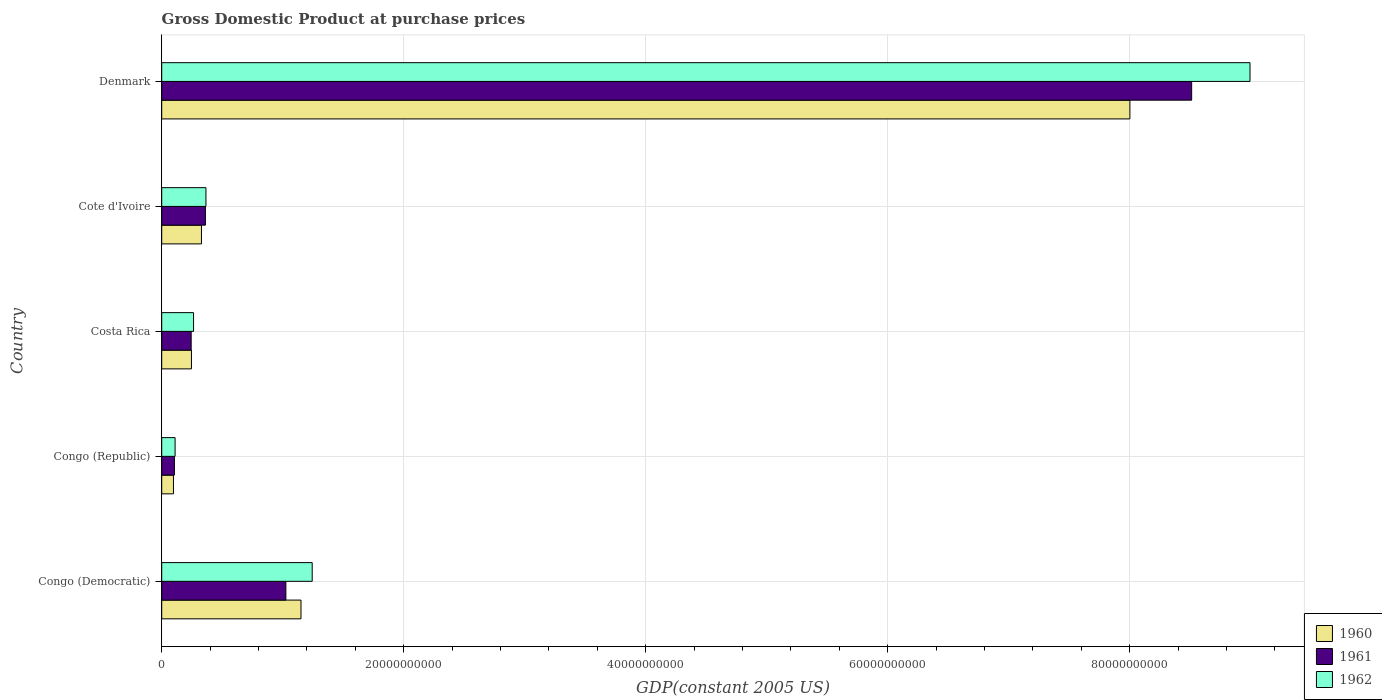How many different coloured bars are there?
Keep it short and to the point. 3. How many groups of bars are there?
Your answer should be very brief. 5. Are the number of bars on each tick of the Y-axis equal?
Ensure brevity in your answer.  Yes. How many bars are there on the 1st tick from the top?
Offer a terse response. 3. How many bars are there on the 2nd tick from the bottom?
Offer a very short reply. 3. In how many cases, is the number of bars for a given country not equal to the number of legend labels?
Give a very brief answer. 0. What is the GDP at purchase prices in 1960 in Costa Rica?
Provide a succinct answer. 2.46e+09. Across all countries, what is the maximum GDP at purchase prices in 1961?
Your answer should be very brief. 8.51e+1. Across all countries, what is the minimum GDP at purchase prices in 1960?
Your answer should be compact. 9.70e+08. In which country was the GDP at purchase prices in 1962 maximum?
Your answer should be compact. Denmark. In which country was the GDP at purchase prices in 1962 minimum?
Offer a terse response. Congo (Republic). What is the total GDP at purchase prices in 1960 in the graph?
Give a very brief answer. 9.82e+1. What is the difference between the GDP at purchase prices in 1961 in Congo (Democratic) and that in Congo (Republic)?
Your answer should be compact. 9.21e+09. What is the difference between the GDP at purchase prices in 1960 in Denmark and the GDP at purchase prices in 1962 in Cote d'Ivoire?
Ensure brevity in your answer.  7.64e+1. What is the average GDP at purchase prices in 1962 per country?
Your answer should be very brief. 2.20e+1. What is the difference between the GDP at purchase prices in 1962 and GDP at purchase prices in 1960 in Denmark?
Give a very brief answer. 9.93e+09. In how many countries, is the GDP at purchase prices in 1960 greater than 84000000000 US$?
Your answer should be very brief. 0. What is the ratio of the GDP at purchase prices in 1962 in Congo (Democratic) to that in Denmark?
Keep it short and to the point. 0.14. What is the difference between the highest and the second highest GDP at purchase prices in 1961?
Give a very brief answer. 7.49e+1. What is the difference between the highest and the lowest GDP at purchase prices in 1962?
Keep it short and to the point. 8.88e+1. Is the sum of the GDP at purchase prices in 1962 in Congo (Democratic) and Costa Rica greater than the maximum GDP at purchase prices in 1961 across all countries?
Offer a very short reply. No. What does the 2nd bar from the top in Congo (Democratic) represents?
Keep it short and to the point. 1961. How many bars are there?
Ensure brevity in your answer.  15. Are all the bars in the graph horizontal?
Offer a terse response. Yes. How many countries are there in the graph?
Make the answer very short. 5. What is the difference between two consecutive major ticks on the X-axis?
Your response must be concise. 2.00e+1. Does the graph contain any zero values?
Provide a succinct answer. No. Does the graph contain grids?
Offer a very short reply. Yes. Where does the legend appear in the graph?
Give a very brief answer. Bottom right. How many legend labels are there?
Keep it short and to the point. 3. What is the title of the graph?
Your answer should be compact. Gross Domestic Product at purchase prices. What is the label or title of the X-axis?
Your response must be concise. GDP(constant 2005 US). What is the GDP(constant 2005 US) in 1960 in Congo (Democratic)?
Your answer should be compact. 1.15e+1. What is the GDP(constant 2005 US) of 1961 in Congo (Democratic)?
Your answer should be very brief. 1.03e+1. What is the GDP(constant 2005 US) in 1962 in Congo (Democratic)?
Keep it short and to the point. 1.24e+1. What is the GDP(constant 2005 US) of 1960 in Congo (Republic)?
Provide a short and direct response. 9.70e+08. What is the GDP(constant 2005 US) of 1961 in Congo (Republic)?
Your answer should be compact. 1.05e+09. What is the GDP(constant 2005 US) of 1962 in Congo (Republic)?
Your answer should be compact. 1.11e+09. What is the GDP(constant 2005 US) of 1960 in Costa Rica?
Give a very brief answer. 2.46e+09. What is the GDP(constant 2005 US) of 1961 in Costa Rica?
Ensure brevity in your answer.  2.43e+09. What is the GDP(constant 2005 US) in 1962 in Costa Rica?
Provide a short and direct response. 2.63e+09. What is the GDP(constant 2005 US) of 1960 in Cote d'Ivoire?
Offer a very short reply. 3.29e+09. What is the GDP(constant 2005 US) of 1961 in Cote d'Ivoire?
Your answer should be very brief. 3.61e+09. What is the GDP(constant 2005 US) in 1962 in Cote d'Ivoire?
Provide a short and direct response. 3.66e+09. What is the GDP(constant 2005 US) of 1960 in Denmark?
Give a very brief answer. 8.00e+1. What is the GDP(constant 2005 US) of 1961 in Denmark?
Offer a very short reply. 8.51e+1. What is the GDP(constant 2005 US) in 1962 in Denmark?
Provide a short and direct response. 8.99e+1. Across all countries, what is the maximum GDP(constant 2005 US) in 1960?
Provide a short and direct response. 8.00e+1. Across all countries, what is the maximum GDP(constant 2005 US) of 1961?
Provide a succinct answer. 8.51e+1. Across all countries, what is the maximum GDP(constant 2005 US) in 1962?
Provide a succinct answer. 8.99e+1. Across all countries, what is the minimum GDP(constant 2005 US) in 1960?
Ensure brevity in your answer.  9.70e+08. Across all countries, what is the minimum GDP(constant 2005 US) of 1961?
Give a very brief answer. 1.05e+09. Across all countries, what is the minimum GDP(constant 2005 US) of 1962?
Keep it short and to the point. 1.11e+09. What is the total GDP(constant 2005 US) in 1960 in the graph?
Give a very brief answer. 9.82e+1. What is the total GDP(constant 2005 US) of 1961 in the graph?
Give a very brief answer. 1.02e+11. What is the total GDP(constant 2005 US) in 1962 in the graph?
Ensure brevity in your answer.  1.10e+11. What is the difference between the GDP(constant 2005 US) in 1960 in Congo (Democratic) and that in Congo (Republic)?
Your response must be concise. 1.05e+1. What is the difference between the GDP(constant 2005 US) of 1961 in Congo (Democratic) and that in Congo (Republic)?
Your response must be concise. 9.21e+09. What is the difference between the GDP(constant 2005 US) in 1962 in Congo (Democratic) and that in Congo (Republic)?
Your answer should be very brief. 1.13e+1. What is the difference between the GDP(constant 2005 US) of 1960 in Congo (Democratic) and that in Costa Rica?
Keep it short and to the point. 9.05e+09. What is the difference between the GDP(constant 2005 US) of 1961 in Congo (Democratic) and that in Costa Rica?
Give a very brief answer. 7.83e+09. What is the difference between the GDP(constant 2005 US) of 1962 in Congo (Democratic) and that in Costa Rica?
Ensure brevity in your answer.  9.80e+09. What is the difference between the GDP(constant 2005 US) of 1960 in Congo (Democratic) and that in Cote d'Ivoire?
Offer a very short reply. 8.22e+09. What is the difference between the GDP(constant 2005 US) in 1961 in Congo (Democratic) and that in Cote d'Ivoire?
Make the answer very short. 6.65e+09. What is the difference between the GDP(constant 2005 US) of 1962 in Congo (Democratic) and that in Cote d'Ivoire?
Provide a short and direct response. 8.78e+09. What is the difference between the GDP(constant 2005 US) of 1960 in Congo (Democratic) and that in Denmark?
Your answer should be very brief. -6.85e+1. What is the difference between the GDP(constant 2005 US) in 1961 in Congo (Democratic) and that in Denmark?
Offer a terse response. -7.49e+1. What is the difference between the GDP(constant 2005 US) of 1962 in Congo (Democratic) and that in Denmark?
Keep it short and to the point. -7.75e+1. What is the difference between the GDP(constant 2005 US) in 1960 in Congo (Republic) and that in Costa Rica?
Your response must be concise. -1.49e+09. What is the difference between the GDP(constant 2005 US) in 1961 in Congo (Republic) and that in Costa Rica?
Give a very brief answer. -1.38e+09. What is the difference between the GDP(constant 2005 US) of 1962 in Congo (Republic) and that in Costa Rica?
Offer a very short reply. -1.53e+09. What is the difference between the GDP(constant 2005 US) in 1960 in Congo (Republic) and that in Cote d'Ivoire?
Make the answer very short. -2.32e+09. What is the difference between the GDP(constant 2005 US) in 1961 in Congo (Republic) and that in Cote d'Ivoire?
Make the answer very short. -2.56e+09. What is the difference between the GDP(constant 2005 US) of 1962 in Congo (Republic) and that in Cote d'Ivoire?
Keep it short and to the point. -2.55e+09. What is the difference between the GDP(constant 2005 US) of 1960 in Congo (Republic) and that in Denmark?
Provide a succinct answer. -7.90e+1. What is the difference between the GDP(constant 2005 US) in 1961 in Congo (Republic) and that in Denmark?
Make the answer very short. -8.41e+1. What is the difference between the GDP(constant 2005 US) of 1962 in Congo (Republic) and that in Denmark?
Ensure brevity in your answer.  -8.88e+1. What is the difference between the GDP(constant 2005 US) in 1960 in Costa Rica and that in Cote d'Ivoire?
Offer a very short reply. -8.28e+08. What is the difference between the GDP(constant 2005 US) of 1961 in Costa Rica and that in Cote d'Ivoire?
Ensure brevity in your answer.  -1.18e+09. What is the difference between the GDP(constant 2005 US) in 1962 in Costa Rica and that in Cote d'Ivoire?
Provide a succinct answer. -1.02e+09. What is the difference between the GDP(constant 2005 US) in 1960 in Costa Rica and that in Denmark?
Your answer should be compact. -7.76e+1. What is the difference between the GDP(constant 2005 US) of 1961 in Costa Rica and that in Denmark?
Make the answer very short. -8.27e+1. What is the difference between the GDP(constant 2005 US) of 1962 in Costa Rica and that in Denmark?
Keep it short and to the point. -8.73e+1. What is the difference between the GDP(constant 2005 US) of 1960 in Cote d'Ivoire and that in Denmark?
Keep it short and to the point. -7.67e+1. What is the difference between the GDP(constant 2005 US) of 1961 in Cote d'Ivoire and that in Denmark?
Your answer should be very brief. -8.15e+1. What is the difference between the GDP(constant 2005 US) of 1962 in Cote d'Ivoire and that in Denmark?
Your answer should be very brief. -8.63e+1. What is the difference between the GDP(constant 2005 US) of 1960 in Congo (Democratic) and the GDP(constant 2005 US) of 1961 in Congo (Republic)?
Provide a short and direct response. 1.05e+1. What is the difference between the GDP(constant 2005 US) of 1960 in Congo (Democratic) and the GDP(constant 2005 US) of 1962 in Congo (Republic)?
Offer a terse response. 1.04e+1. What is the difference between the GDP(constant 2005 US) in 1961 in Congo (Democratic) and the GDP(constant 2005 US) in 1962 in Congo (Republic)?
Make the answer very short. 9.16e+09. What is the difference between the GDP(constant 2005 US) of 1960 in Congo (Democratic) and the GDP(constant 2005 US) of 1961 in Costa Rica?
Provide a short and direct response. 9.08e+09. What is the difference between the GDP(constant 2005 US) of 1960 in Congo (Democratic) and the GDP(constant 2005 US) of 1962 in Costa Rica?
Your answer should be compact. 8.88e+09. What is the difference between the GDP(constant 2005 US) in 1961 in Congo (Democratic) and the GDP(constant 2005 US) in 1962 in Costa Rica?
Provide a succinct answer. 7.63e+09. What is the difference between the GDP(constant 2005 US) in 1960 in Congo (Democratic) and the GDP(constant 2005 US) in 1961 in Cote d'Ivoire?
Ensure brevity in your answer.  7.90e+09. What is the difference between the GDP(constant 2005 US) in 1960 in Congo (Democratic) and the GDP(constant 2005 US) in 1962 in Cote d'Ivoire?
Your answer should be compact. 7.85e+09. What is the difference between the GDP(constant 2005 US) of 1961 in Congo (Democratic) and the GDP(constant 2005 US) of 1962 in Cote d'Ivoire?
Keep it short and to the point. 6.60e+09. What is the difference between the GDP(constant 2005 US) in 1960 in Congo (Democratic) and the GDP(constant 2005 US) in 1961 in Denmark?
Keep it short and to the point. -7.36e+1. What is the difference between the GDP(constant 2005 US) of 1960 in Congo (Democratic) and the GDP(constant 2005 US) of 1962 in Denmark?
Provide a succinct answer. -7.84e+1. What is the difference between the GDP(constant 2005 US) in 1961 in Congo (Democratic) and the GDP(constant 2005 US) in 1962 in Denmark?
Provide a short and direct response. -7.97e+1. What is the difference between the GDP(constant 2005 US) in 1960 in Congo (Republic) and the GDP(constant 2005 US) in 1961 in Costa Rica?
Provide a short and direct response. -1.46e+09. What is the difference between the GDP(constant 2005 US) in 1960 in Congo (Republic) and the GDP(constant 2005 US) in 1962 in Costa Rica?
Your answer should be compact. -1.66e+09. What is the difference between the GDP(constant 2005 US) of 1961 in Congo (Republic) and the GDP(constant 2005 US) of 1962 in Costa Rica?
Give a very brief answer. -1.58e+09. What is the difference between the GDP(constant 2005 US) of 1960 in Congo (Republic) and the GDP(constant 2005 US) of 1961 in Cote d'Ivoire?
Your response must be concise. -2.64e+09. What is the difference between the GDP(constant 2005 US) of 1960 in Congo (Republic) and the GDP(constant 2005 US) of 1962 in Cote d'Ivoire?
Your response must be concise. -2.69e+09. What is the difference between the GDP(constant 2005 US) in 1961 in Congo (Republic) and the GDP(constant 2005 US) in 1962 in Cote d'Ivoire?
Your answer should be very brief. -2.61e+09. What is the difference between the GDP(constant 2005 US) of 1960 in Congo (Republic) and the GDP(constant 2005 US) of 1961 in Denmark?
Ensure brevity in your answer.  -8.42e+1. What is the difference between the GDP(constant 2005 US) of 1960 in Congo (Republic) and the GDP(constant 2005 US) of 1962 in Denmark?
Offer a very short reply. -8.90e+1. What is the difference between the GDP(constant 2005 US) in 1961 in Congo (Republic) and the GDP(constant 2005 US) in 1962 in Denmark?
Your answer should be compact. -8.89e+1. What is the difference between the GDP(constant 2005 US) of 1960 in Costa Rica and the GDP(constant 2005 US) of 1961 in Cote d'Ivoire?
Keep it short and to the point. -1.15e+09. What is the difference between the GDP(constant 2005 US) of 1960 in Costa Rica and the GDP(constant 2005 US) of 1962 in Cote d'Ivoire?
Give a very brief answer. -1.20e+09. What is the difference between the GDP(constant 2005 US) in 1961 in Costa Rica and the GDP(constant 2005 US) in 1962 in Cote d'Ivoire?
Provide a succinct answer. -1.22e+09. What is the difference between the GDP(constant 2005 US) in 1960 in Costa Rica and the GDP(constant 2005 US) in 1961 in Denmark?
Your answer should be very brief. -8.27e+1. What is the difference between the GDP(constant 2005 US) in 1960 in Costa Rica and the GDP(constant 2005 US) in 1962 in Denmark?
Give a very brief answer. -8.75e+1. What is the difference between the GDP(constant 2005 US) of 1961 in Costa Rica and the GDP(constant 2005 US) of 1962 in Denmark?
Your answer should be very brief. -8.75e+1. What is the difference between the GDP(constant 2005 US) of 1960 in Cote d'Ivoire and the GDP(constant 2005 US) of 1961 in Denmark?
Keep it short and to the point. -8.18e+1. What is the difference between the GDP(constant 2005 US) of 1960 in Cote d'Ivoire and the GDP(constant 2005 US) of 1962 in Denmark?
Your answer should be compact. -8.67e+1. What is the difference between the GDP(constant 2005 US) in 1961 in Cote d'Ivoire and the GDP(constant 2005 US) in 1962 in Denmark?
Ensure brevity in your answer.  -8.63e+1. What is the average GDP(constant 2005 US) of 1960 per country?
Offer a terse response. 1.96e+1. What is the average GDP(constant 2005 US) of 1961 per country?
Offer a very short reply. 2.05e+1. What is the average GDP(constant 2005 US) in 1962 per country?
Make the answer very short. 2.20e+1. What is the difference between the GDP(constant 2005 US) of 1960 and GDP(constant 2005 US) of 1961 in Congo (Democratic)?
Your response must be concise. 1.25e+09. What is the difference between the GDP(constant 2005 US) in 1960 and GDP(constant 2005 US) in 1962 in Congo (Democratic)?
Provide a short and direct response. -9.26e+08. What is the difference between the GDP(constant 2005 US) in 1961 and GDP(constant 2005 US) in 1962 in Congo (Democratic)?
Offer a terse response. -2.18e+09. What is the difference between the GDP(constant 2005 US) in 1960 and GDP(constant 2005 US) in 1961 in Congo (Republic)?
Provide a short and direct response. -8.10e+07. What is the difference between the GDP(constant 2005 US) in 1960 and GDP(constant 2005 US) in 1962 in Congo (Republic)?
Offer a very short reply. -1.36e+08. What is the difference between the GDP(constant 2005 US) of 1961 and GDP(constant 2005 US) of 1962 in Congo (Republic)?
Give a very brief answer. -5.47e+07. What is the difference between the GDP(constant 2005 US) in 1960 and GDP(constant 2005 US) in 1961 in Costa Rica?
Ensure brevity in your answer.  2.35e+07. What is the difference between the GDP(constant 2005 US) of 1960 and GDP(constant 2005 US) of 1962 in Costa Rica?
Your response must be concise. -1.75e+08. What is the difference between the GDP(constant 2005 US) of 1961 and GDP(constant 2005 US) of 1962 in Costa Rica?
Make the answer very short. -1.98e+08. What is the difference between the GDP(constant 2005 US) in 1960 and GDP(constant 2005 US) in 1961 in Cote d'Ivoire?
Give a very brief answer. -3.26e+08. What is the difference between the GDP(constant 2005 US) in 1960 and GDP(constant 2005 US) in 1962 in Cote d'Ivoire?
Offer a very short reply. -3.71e+08. What is the difference between the GDP(constant 2005 US) in 1961 and GDP(constant 2005 US) in 1962 in Cote d'Ivoire?
Ensure brevity in your answer.  -4.43e+07. What is the difference between the GDP(constant 2005 US) in 1960 and GDP(constant 2005 US) in 1961 in Denmark?
Your answer should be very brief. -5.10e+09. What is the difference between the GDP(constant 2005 US) of 1960 and GDP(constant 2005 US) of 1962 in Denmark?
Offer a very short reply. -9.93e+09. What is the difference between the GDP(constant 2005 US) of 1961 and GDP(constant 2005 US) of 1962 in Denmark?
Offer a very short reply. -4.82e+09. What is the ratio of the GDP(constant 2005 US) of 1960 in Congo (Democratic) to that in Congo (Republic)?
Your answer should be compact. 11.87. What is the ratio of the GDP(constant 2005 US) in 1961 in Congo (Democratic) to that in Congo (Republic)?
Make the answer very short. 9.76. What is the ratio of the GDP(constant 2005 US) in 1962 in Congo (Democratic) to that in Congo (Republic)?
Ensure brevity in your answer.  11.25. What is the ratio of the GDP(constant 2005 US) in 1960 in Congo (Democratic) to that in Costa Rica?
Your answer should be compact. 4.68. What is the ratio of the GDP(constant 2005 US) in 1961 in Congo (Democratic) to that in Costa Rica?
Provide a succinct answer. 4.22. What is the ratio of the GDP(constant 2005 US) of 1962 in Congo (Democratic) to that in Costa Rica?
Give a very brief answer. 4.72. What is the ratio of the GDP(constant 2005 US) of 1960 in Congo (Democratic) to that in Cote d'Ivoire?
Give a very brief answer. 3.5. What is the ratio of the GDP(constant 2005 US) in 1961 in Congo (Democratic) to that in Cote d'Ivoire?
Ensure brevity in your answer.  2.84. What is the ratio of the GDP(constant 2005 US) of 1962 in Congo (Democratic) to that in Cote d'Ivoire?
Make the answer very short. 3.4. What is the ratio of the GDP(constant 2005 US) of 1960 in Congo (Democratic) to that in Denmark?
Provide a succinct answer. 0.14. What is the ratio of the GDP(constant 2005 US) of 1961 in Congo (Democratic) to that in Denmark?
Your answer should be very brief. 0.12. What is the ratio of the GDP(constant 2005 US) of 1962 in Congo (Democratic) to that in Denmark?
Offer a terse response. 0.14. What is the ratio of the GDP(constant 2005 US) of 1960 in Congo (Republic) to that in Costa Rica?
Provide a short and direct response. 0.39. What is the ratio of the GDP(constant 2005 US) of 1961 in Congo (Republic) to that in Costa Rica?
Offer a very short reply. 0.43. What is the ratio of the GDP(constant 2005 US) in 1962 in Congo (Republic) to that in Costa Rica?
Your answer should be very brief. 0.42. What is the ratio of the GDP(constant 2005 US) of 1960 in Congo (Republic) to that in Cote d'Ivoire?
Keep it short and to the point. 0.3. What is the ratio of the GDP(constant 2005 US) in 1961 in Congo (Republic) to that in Cote d'Ivoire?
Give a very brief answer. 0.29. What is the ratio of the GDP(constant 2005 US) in 1962 in Congo (Republic) to that in Cote d'Ivoire?
Your answer should be very brief. 0.3. What is the ratio of the GDP(constant 2005 US) of 1960 in Congo (Republic) to that in Denmark?
Provide a succinct answer. 0.01. What is the ratio of the GDP(constant 2005 US) in 1961 in Congo (Republic) to that in Denmark?
Your answer should be very brief. 0.01. What is the ratio of the GDP(constant 2005 US) of 1962 in Congo (Republic) to that in Denmark?
Offer a very short reply. 0.01. What is the ratio of the GDP(constant 2005 US) of 1960 in Costa Rica to that in Cote d'Ivoire?
Make the answer very short. 0.75. What is the ratio of the GDP(constant 2005 US) in 1961 in Costa Rica to that in Cote d'Ivoire?
Make the answer very short. 0.67. What is the ratio of the GDP(constant 2005 US) of 1962 in Costa Rica to that in Cote d'Ivoire?
Offer a very short reply. 0.72. What is the ratio of the GDP(constant 2005 US) in 1960 in Costa Rica to that in Denmark?
Keep it short and to the point. 0.03. What is the ratio of the GDP(constant 2005 US) of 1961 in Costa Rica to that in Denmark?
Give a very brief answer. 0.03. What is the ratio of the GDP(constant 2005 US) in 1962 in Costa Rica to that in Denmark?
Your answer should be compact. 0.03. What is the ratio of the GDP(constant 2005 US) of 1960 in Cote d'Ivoire to that in Denmark?
Ensure brevity in your answer.  0.04. What is the ratio of the GDP(constant 2005 US) of 1961 in Cote d'Ivoire to that in Denmark?
Your answer should be very brief. 0.04. What is the ratio of the GDP(constant 2005 US) in 1962 in Cote d'Ivoire to that in Denmark?
Provide a short and direct response. 0.04. What is the difference between the highest and the second highest GDP(constant 2005 US) in 1960?
Your answer should be compact. 6.85e+1. What is the difference between the highest and the second highest GDP(constant 2005 US) of 1961?
Offer a very short reply. 7.49e+1. What is the difference between the highest and the second highest GDP(constant 2005 US) in 1962?
Offer a terse response. 7.75e+1. What is the difference between the highest and the lowest GDP(constant 2005 US) in 1960?
Provide a succinct answer. 7.90e+1. What is the difference between the highest and the lowest GDP(constant 2005 US) in 1961?
Give a very brief answer. 8.41e+1. What is the difference between the highest and the lowest GDP(constant 2005 US) in 1962?
Give a very brief answer. 8.88e+1. 